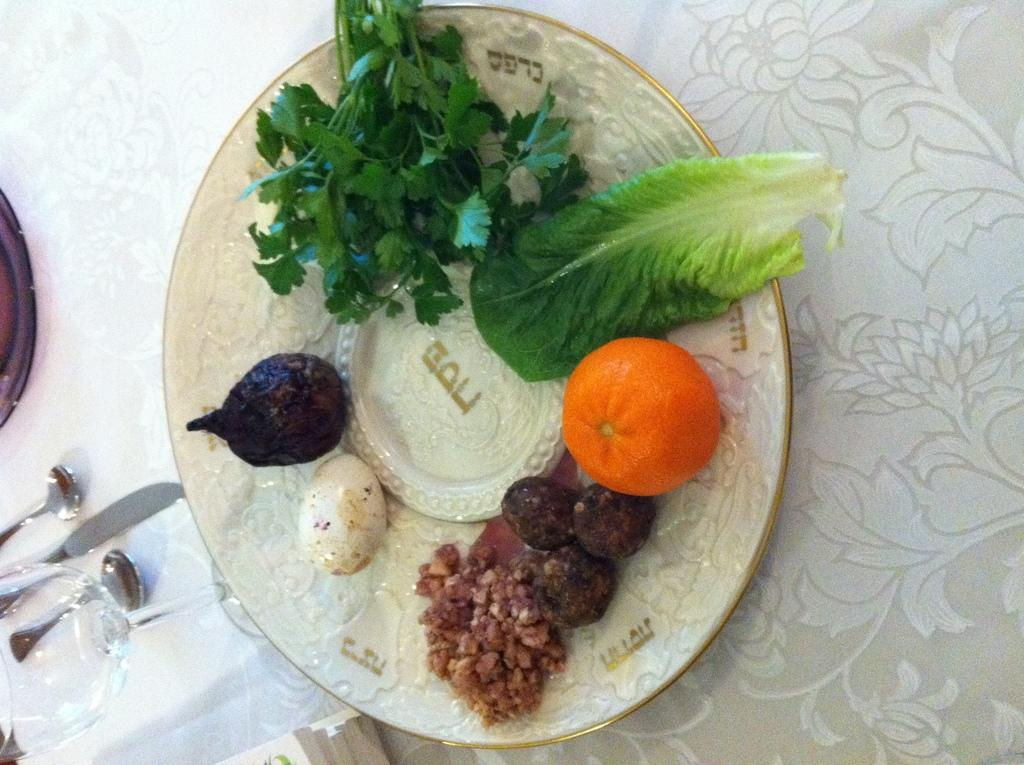What is on the plate that is visible in the image? There is food on a plate in the image. Where is the plate located in the image? The plate is in the center of the image. What utensils are on the left side of the plate? There are spoons, a glass, and a knife on the left side of the plate. What type of ink is used to write on the plate in the image? There is no ink or writing present on the plate in the image. 